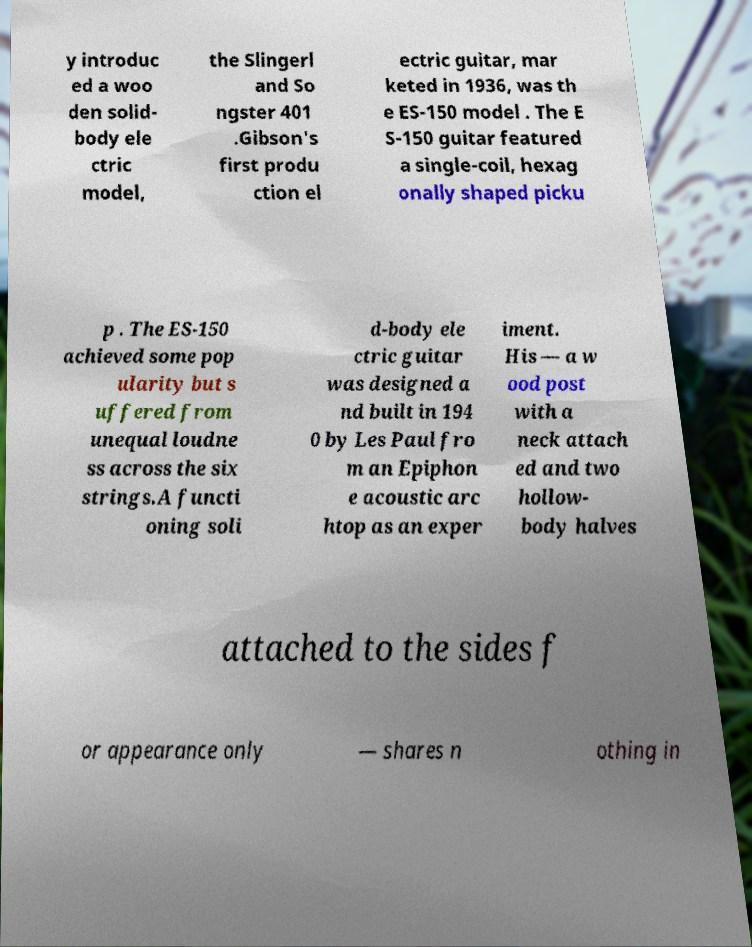What messages or text are displayed in this image? I need them in a readable, typed format. y introduc ed a woo den solid- body ele ctric model, the Slingerl and So ngster 401 .Gibson's first produ ction el ectric guitar, mar keted in 1936, was th e ES-150 model . The E S-150 guitar featured a single-coil, hexag onally shaped picku p . The ES-150 achieved some pop ularity but s uffered from unequal loudne ss across the six strings.A functi oning soli d-body ele ctric guitar was designed a nd built in 194 0 by Les Paul fro m an Epiphon e acoustic arc htop as an exper iment. His — a w ood post with a neck attach ed and two hollow- body halves attached to the sides f or appearance only — shares n othing in 